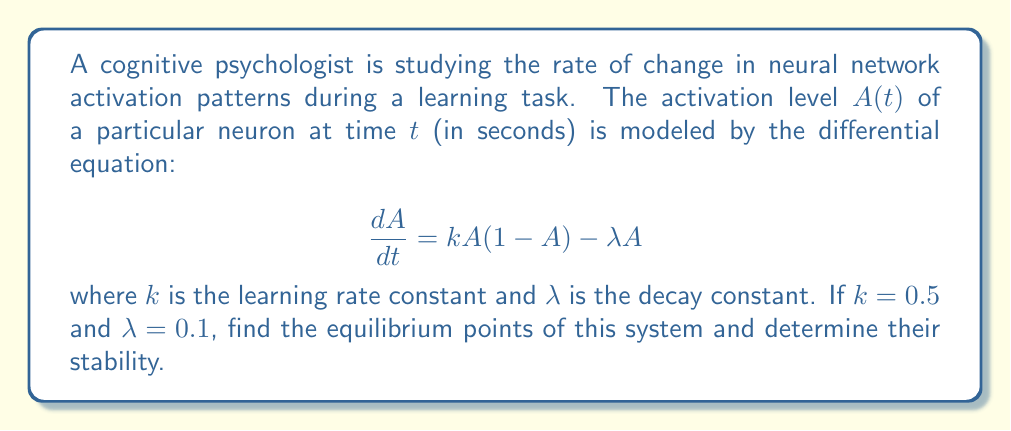Help me with this question. To solve this problem, we'll follow these steps:

1) First, we need to find the equilibrium points. These are the points where the rate of change is zero, i.e., $\frac{dA}{dt} = 0$.

2) Set the differential equation to zero:

   $$0 = kA(1-A) - \lambda A$$

3) Substitute the given values $k = 0.5$ and $\lambda = 0.1$:

   $$0 = 0.5A(1-A) - 0.1A$$

4) Simplify:

   $$0 = 0.5A - 0.5A^2 - 0.1A = 0.4A - 0.5A^2$$

5) Factor out $A$:

   $$A(0.4 - 0.5A) = 0$$

6) Solve this equation. Either $A = 0$ or $0.4 - 0.5A = 0$:

   For the second part: $0.4 - 0.5A = 0$
                        $-0.5A = -0.4$
                        $A = 0.8$

   So, the equilibrium points are $A = 0$ and $A = 0.8$.

7) To determine stability, we need to look at the derivative of $\frac{dA}{dt}$ with respect to $A$ at each equilibrium point:

   $$\frac{d}{dA}(\frac{dA}{dt}) = k(1-2A) - \lambda = 0.5(1-2A) - 0.1$$

8) At $A = 0$:
   $$0.5(1-2(0)) - 0.1 = 0.5 - 0.1 = 0.4 > 0$$
   This is positive, so $A = 0$ is an unstable equilibrium point.

9) At $A = 0.8$:
   $$0.5(1-2(0.8)) - 0.1 = 0.5(-0.6) - 0.1 = -0.3 - 0.1 = -0.4 < 0$$
   This is negative, so $A = 0.8$ is a stable equilibrium point.
Answer: The equilibrium points are $A = 0$ (unstable) and $A = 0.8$ (stable). 